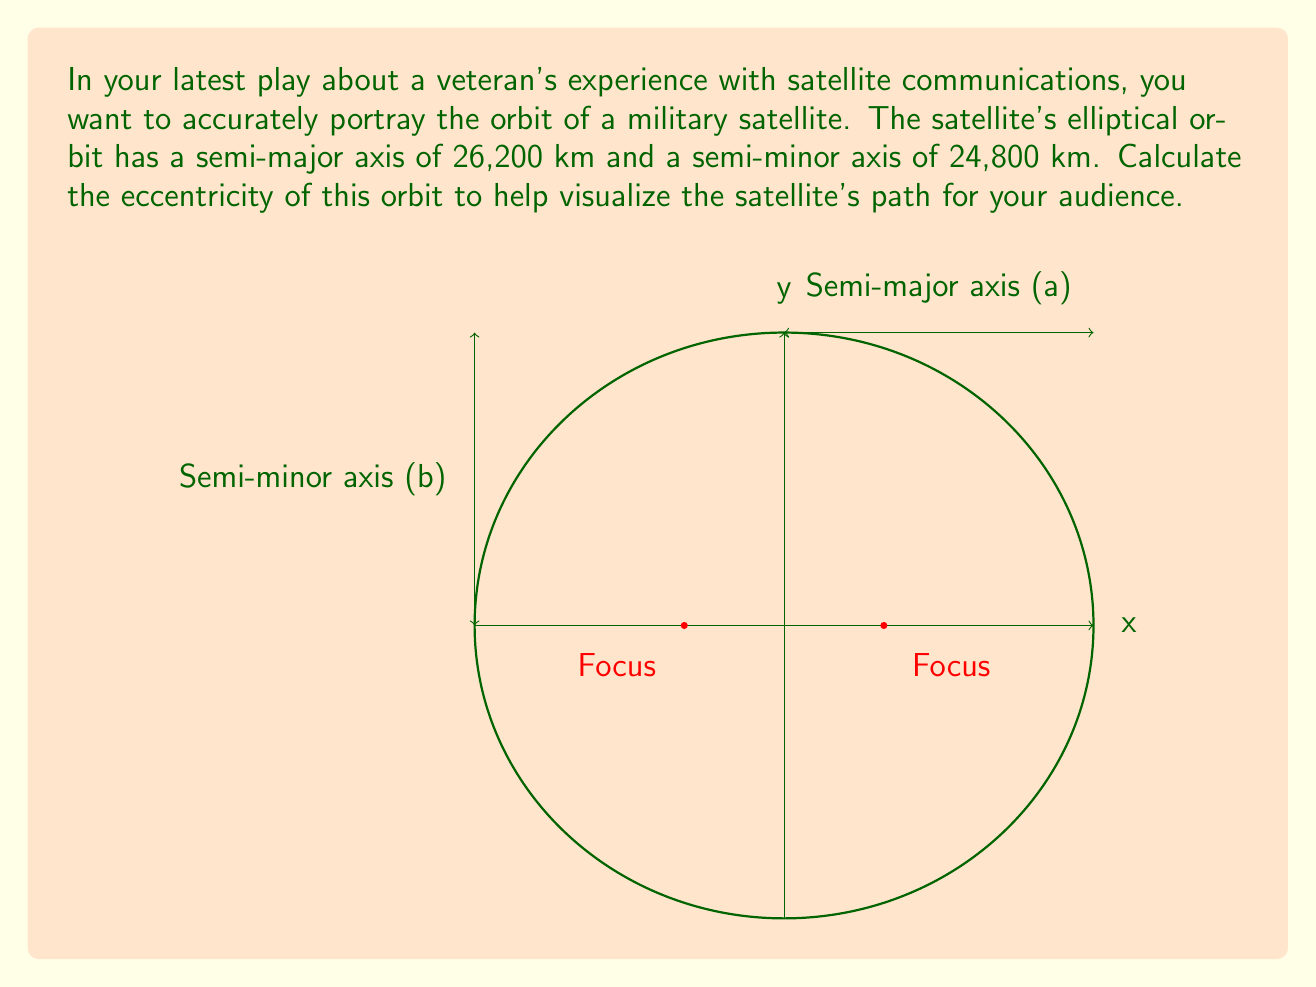Show me your answer to this math problem. To find the eccentricity of an elliptical orbit, we'll follow these steps:

1) The eccentricity (e) of an ellipse is given by the formula:

   $$e = \sqrt{1 - \frac{b^2}{a^2}}$$

   where $a$ is the semi-major axis and $b$ is the semi-minor axis.

2) We're given:
   $a = 26,200$ km
   $b = 24,800$ km

3) Let's substitute these values into the formula:

   $$e = \sqrt{1 - \frac{24,800^2}{26,200^2}}$$

4) Simplify the fraction inside the square root:

   $$e = \sqrt{1 - \frac{615,040,000}{686,440,000}}$$

5) Perform the division:

   $$e = \sqrt{1 - 0.8960}$$

6) Subtract:

   $$e = \sqrt{0.1040}$$

7) Calculate the square root:

   $$e \approx 0.3225$$

This value represents the eccentricity of the satellite's orbit.
Answer: $e \approx 0.3225$ 